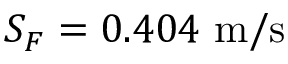Convert formula to latex. <formula><loc_0><loc_0><loc_500><loc_500>S _ { F } = 0 . 4 0 4 m / s</formula> 